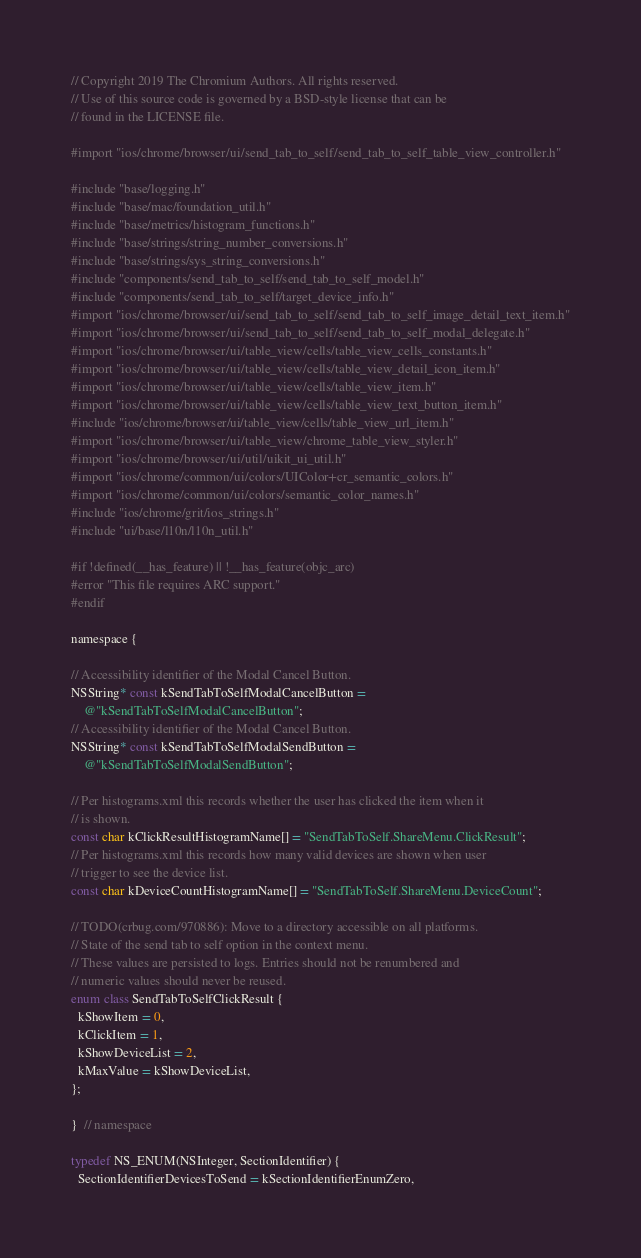<code> <loc_0><loc_0><loc_500><loc_500><_ObjectiveC_>// Copyright 2019 The Chromium Authors. All rights reserved.
// Use of this source code is governed by a BSD-style license that can be
// found in the LICENSE file.

#import "ios/chrome/browser/ui/send_tab_to_self/send_tab_to_self_table_view_controller.h"

#include "base/logging.h"
#include "base/mac/foundation_util.h"
#include "base/metrics/histogram_functions.h"
#include "base/strings/string_number_conversions.h"
#include "base/strings/sys_string_conversions.h"
#include "components/send_tab_to_self/send_tab_to_self_model.h"
#include "components/send_tab_to_self/target_device_info.h"
#import "ios/chrome/browser/ui/send_tab_to_self/send_tab_to_self_image_detail_text_item.h"
#import "ios/chrome/browser/ui/send_tab_to_self/send_tab_to_self_modal_delegate.h"
#import "ios/chrome/browser/ui/table_view/cells/table_view_cells_constants.h"
#import "ios/chrome/browser/ui/table_view/cells/table_view_detail_icon_item.h"
#import "ios/chrome/browser/ui/table_view/cells/table_view_item.h"
#import "ios/chrome/browser/ui/table_view/cells/table_view_text_button_item.h"
#include "ios/chrome/browser/ui/table_view/cells/table_view_url_item.h"
#import "ios/chrome/browser/ui/table_view/chrome_table_view_styler.h"
#import "ios/chrome/browser/ui/util/uikit_ui_util.h"
#import "ios/chrome/common/ui/colors/UIColor+cr_semantic_colors.h"
#import "ios/chrome/common/ui/colors/semantic_color_names.h"
#include "ios/chrome/grit/ios_strings.h"
#include "ui/base/l10n/l10n_util.h"

#if !defined(__has_feature) || !__has_feature(objc_arc)
#error "This file requires ARC support."
#endif

namespace {

// Accessibility identifier of the Modal Cancel Button.
NSString* const kSendTabToSelfModalCancelButton =
    @"kSendTabToSelfModalCancelButton";
// Accessibility identifier of the Modal Cancel Button.
NSString* const kSendTabToSelfModalSendButton =
    @"kSendTabToSelfModalSendButton";

// Per histograms.xml this records whether the user has clicked the item when it
// is shown.
const char kClickResultHistogramName[] = "SendTabToSelf.ShareMenu.ClickResult";
// Per histograms.xml this records how many valid devices are shown when user
// trigger to see the device list.
const char kDeviceCountHistogramName[] = "SendTabToSelf.ShareMenu.DeviceCount";

// TODO(crbug.com/970886): Move to a directory accessible on all platforms.
// State of the send tab to self option in the context menu.
// These values are persisted to logs. Entries should not be renumbered and
// numeric values should never be reused.
enum class SendTabToSelfClickResult {
  kShowItem = 0,
  kClickItem = 1,
  kShowDeviceList = 2,
  kMaxValue = kShowDeviceList,
};

}  // namespace

typedef NS_ENUM(NSInteger, SectionIdentifier) {
  SectionIdentifierDevicesToSend = kSectionIdentifierEnumZero,</code> 